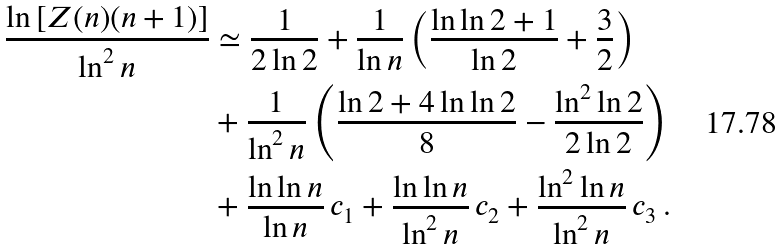<formula> <loc_0><loc_0><loc_500><loc_500>\frac { \ln \left [ Z ( n ) ( n + 1 ) \right ] } { \ln ^ { 2 } n } & \simeq \frac { 1 } { 2 \ln 2 } + \frac { 1 } { \ln n } \left ( \frac { \ln \ln 2 + 1 } { \ln { 2 } } + \frac { 3 } { 2 } \right ) \\ & + \frac { 1 } { \ln ^ { 2 } n } \left ( \frac { \ln 2 + 4 \ln \ln 2 } { 8 } - \frac { \ln ^ { 2 } \ln 2 } { 2 \ln 2 } \right ) \\ & + \frac { \ln \ln n } { \ln n } \, c _ { 1 } + \frac { \ln \ln n } { \ln ^ { 2 } n } \, c _ { 2 } + \frac { \ln ^ { 2 } \ln n } { \ln ^ { 2 } n } \, c _ { 3 } \, .</formula> 